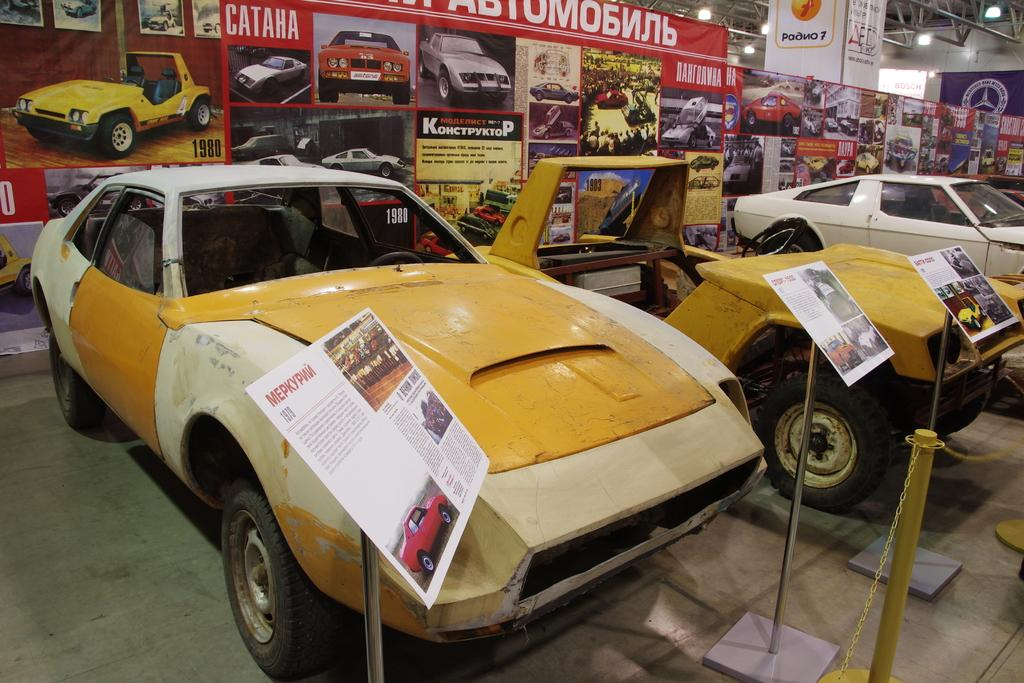What type of vehicles can be seen in the image? There are cars in the image. What else is present in the image besides the cars? There are stands with posters in the image. Can you describe the posters in the image? There are stands with posters, and there is a poster visible behind the stands. How many hours of sleep do the cars need in the image? Cars do not require sleep, as they are inanimate objects. 